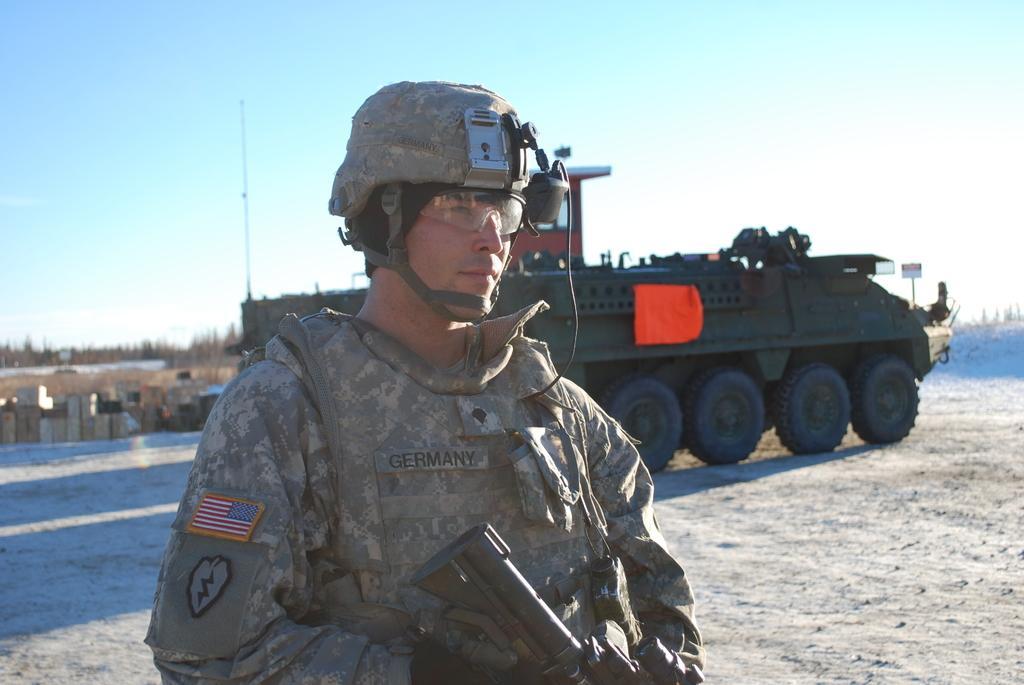Please provide a concise description of this image. In this image, we can see a person in a military uniform wearing helmet and goggles. He is holding a gun. Background we can see vehicle, few objects, road, trees, pole and sky. Here it looks like a buildings. 